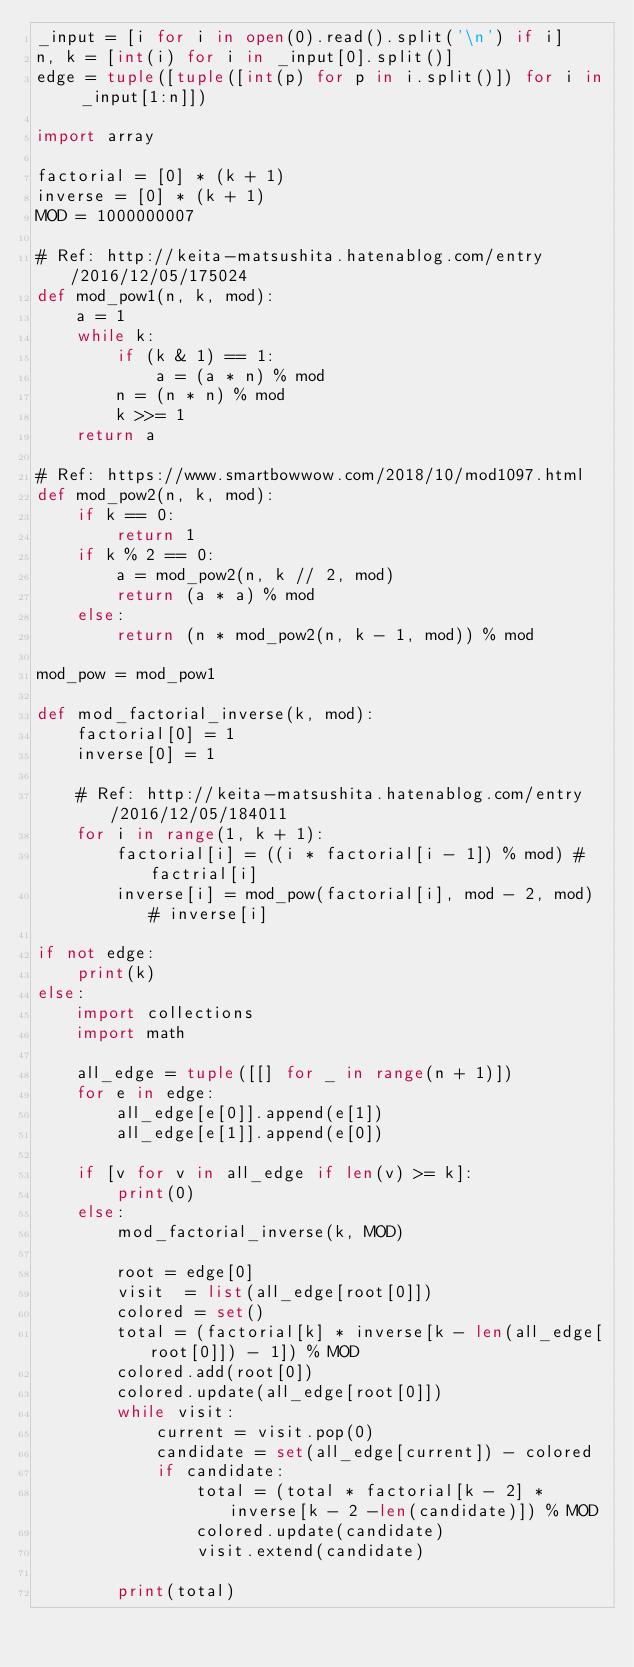<code> <loc_0><loc_0><loc_500><loc_500><_Python_>_input = [i for i in open(0).read().split('\n') if i]
n, k = [int(i) for i in _input[0].split()]
edge = tuple([tuple([int(p) for p in i.split()]) for i in _input[1:n]])

import array

factorial = [0] * (k + 1)
inverse = [0] * (k + 1)
MOD = 1000000007

# Ref: http://keita-matsushita.hatenablog.com/entry/2016/12/05/175024
def mod_pow1(n, k, mod):
    a = 1
    while k:
        if (k & 1) == 1:
            a = (a * n) % mod
        n = (n * n) % mod
        k >>= 1
    return a

# Ref: https://www.smartbowwow.com/2018/10/mod1097.html
def mod_pow2(n, k, mod):
    if k == 0:
        return 1
    if k % 2 == 0:
        a = mod_pow2(n, k // 2, mod)
        return (a * a) % mod
    else:
        return (n * mod_pow2(n, k - 1, mod)) % mod

mod_pow = mod_pow1

def mod_factorial_inverse(k, mod):
    factorial[0] = 1
    inverse[0] = 1

    # Ref: http://keita-matsushita.hatenablog.com/entry/2016/12/05/184011
    for i in range(1, k + 1):
        factorial[i] = ((i * factorial[i - 1]) % mod) # factrial[i]
        inverse[i] = mod_pow(factorial[i], mod - 2, mod) # inverse[i]
 
if not edge:
    print(k)
else:
    import collections
    import math
 
    all_edge = tuple([[] for _ in range(n + 1)])
    for e in edge:
        all_edge[e[0]].append(e[1])
        all_edge[e[1]].append(e[0])

    if [v for v in all_edge if len(v) >= k]:
        print(0)
    else:
        mod_factorial_inverse(k, MOD)

        root = edge[0]
        visit  = list(all_edge[root[0]])
        colored = set()
        total = (factorial[k] * inverse[k - len(all_edge[root[0]]) - 1]) % MOD
        colored.add(root[0])
        colored.update(all_edge[root[0]])
        while visit:
            current = visit.pop(0)
            candidate = set(all_edge[current]) - colored
            if candidate:
                total = (total * factorial[k - 2] * inverse[k - 2 -len(candidate)]) % MOD
                colored.update(candidate)
                visit.extend(candidate)

        print(total)
</code> 